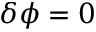Convert formula to latex. <formula><loc_0><loc_0><loc_500><loc_500>\delta \phi = 0</formula> 